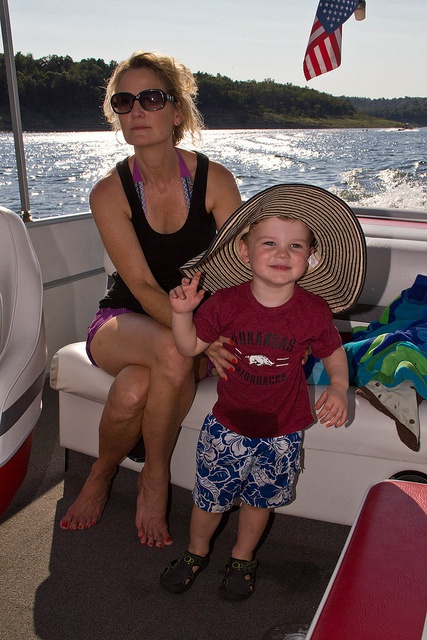Describe the objects in this image and their specific colors. I can see people in black, maroon, and brown tones and people in black, maroon, brown, and gray tones in this image. 